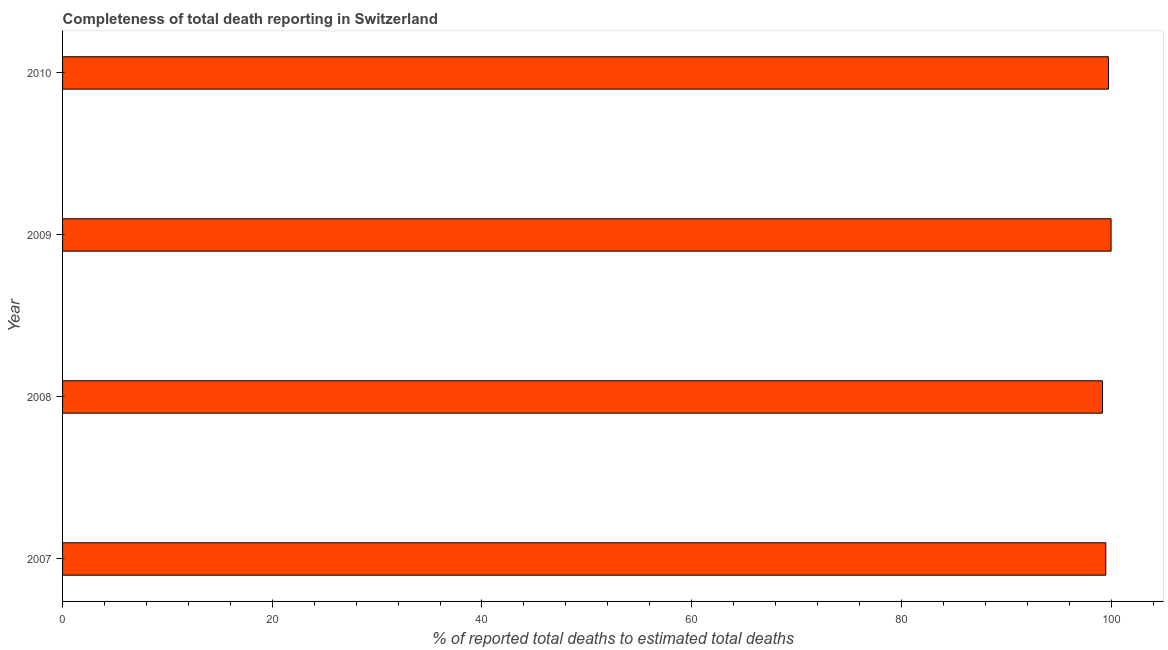What is the title of the graph?
Offer a very short reply. Completeness of total death reporting in Switzerland. What is the label or title of the X-axis?
Your answer should be compact. % of reported total deaths to estimated total deaths. What is the completeness of total death reports in 2010?
Provide a short and direct response. 99.75. Across all years, what is the maximum completeness of total death reports?
Provide a short and direct response. 100. Across all years, what is the minimum completeness of total death reports?
Your answer should be compact. 99.18. What is the sum of the completeness of total death reports?
Ensure brevity in your answer.  398.43. What is the difference between the completeness of total death reports in 2007 and 2010?
Your answer should be very brief. -0.25. What is the average completeness of total death reports per year?
Your response must be concise. 99.61. What is the median completeness of total death reports?
Ensure brevity in your answer.  99.62. Is the difference between the completeness of total death reports in 2008 and 2010 greater than the difference between any two years?
Provide a short and direct response. No. What is the difference between the highest and the second highest completeness of total death reports?
Your answer should be very brief. 0.25. What is the difference between the highest and the lowest completeness of total death reports?
Give a very brief answer. 0.82. How many bars are there?
Offer a very short reply. 4. What is the % of reported total deaths to estimated total deaths in 2007?
Provide a short and direct response. 99.5. What is the % of reported total deaths to estimated total deaths in 2008?
Your response must be concise. 99.18. What is the % of reported total deaths to estimated total deaths of 2010?
Ensure brevity in your answer.  99.75. What is the difference between the % of reported total deaths to estimated total deaths in 2007 and 2008?
Your response must be concise. 0.32. What is the difference between the % of reported total deaths to estimated total deaths in 2007 and 2009?
Provide a short and direct response. -0.5. What is the difference between the % of reported total deaths to estimated total deaths in 2007 and 2010?
Provide a succinct answer. -0.25. What is the difference between the % of reported total deaths to estimated total deaths in 2008 and 2009?
Ensure brevity in your answer.  -0.82. What is the difference between the % of reported total deaths to estimated total deaths in 2008 and 2010?
Your answer should be compact. -0.57. What is the difference between the % of reported total deaths to estimated total deaths in 2009 and 2010?
Provide a short and direct response. 0.25. What is the ratio of the % of reported total deaths to estimated total deaths in 2007 to that in 2008?
Offer a terse response. 1. 